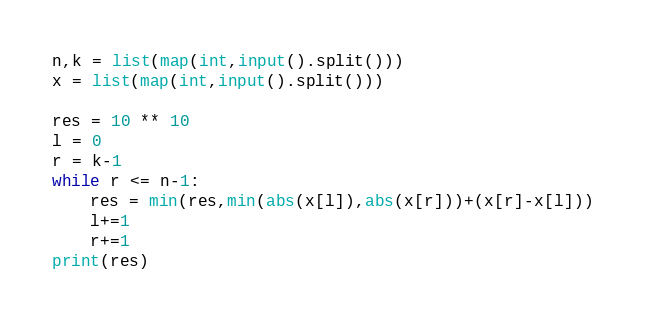<code> <loc_0><loc_0><loc_500><loc_500><_Python_>n,k = list(map(int,input().split()))
x = list(map(int,input().split()))

res = 10 ** 10
l = 0
r = k-1
while r <= n-1:
    res = min(res,min(abs(x[l]),abs(x[r]))+(x[r]-x[l]))
    l+=1
    r+=1
print(res)
</code> 